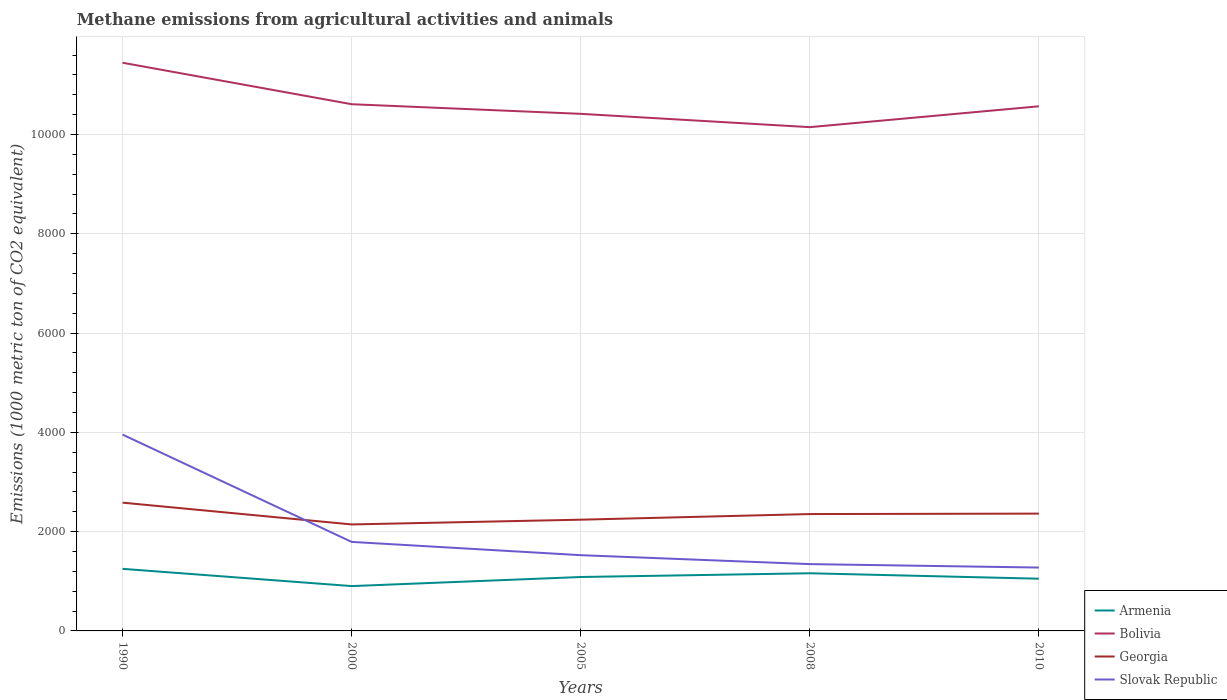Across all years, what is the maximum amount of methane emitted in Slovak Republic?
Provide a succinct answer. 1276.7. In which year was the amount of methane emitted in Armenia maximum?
Offer a terse response. 2000. What is the total amount of methane emitted in Armenia in the graph?
Give a very brief answer. 109.8. What is the difference between the highest and the second highest amount of methane emitted in Bolivia?
Provide a short and direct response. 1297.5. How many lines are there?
Keep it short and to the point. 4. What is the difference between two consecutive major ticks on the Y-axis?
Keep it short and to the point. 2000. Are the values on the major ticks of Y-axis written in scientific E-notation?
Your answer should be compact. No. Does the graph contain any zero values?
Provide a succinct answer. No. How many legend labels are there?
Provide a short and direct response. 4. What is the title of the graph?
Your answer should be very brief. Methane emissions from agricultural activities and animals. What is the label or title of the X-axis?
Your answer should be very brief. Years. What is the label or title of the Y-axis?
Offer a very short reply. Emissions (1000 metric ton of CO2 equivalent). What is the Emissions (1000 metric ton of CO2 equivalent) of Armenia in 1990?
Offer a terse response. 1250.4. What is the Emissions (1000 metric ton of CO2 equivalent) in Bolivia in 1990?
Provide a short and direct response. 1.14e+04. What is the Emissions (1000 metric ton of CO2 equivalent) of Georgia in 1990?
Keep it short and to the point. 2583.7. What is the Emissions (1000 metric ton of CO2 equivalent) in Slovak Republic in 1990?
Ensure brevity in your answer.  3954.5. What is the Emissions (1000 metric ton of CO2 equivalent) of Armenia in 2000?
Offer a terse response. 903.1. What is the Emissions (1000 metric ton of CO2 equivalent) of Bolivia in 2000?
Ensure brevity in your answer.  1.06e+04. What is the Emissions (1000 metric ton of CO2 equivalent) in Georgia in 2000?
Provide a succinct answer. 2145. What is the Emissions (1000 metric ton of CO2 equivalent) of Slovak Republic in 2000?
Provide a short and direct response. 1793.2. What is the Emissions (1000 metric ton of CO2 equivalent) of Armenia in 2005?
Your response must be concise. 1086. What is the Emissions (1000 metric ton of CO2 equivalent) of Bolivia in 2005?
Keep it short and to the point. 1.04e+04. What is the Emissions (1000 metric ton of CO2 equivalent) in Georgia in 2005?
Your response must be concise. 2240.7. What is the Emissions (1000 metric ton of CO2 equivalent) of Slovak Republic in 2005?
Make the answer very short. 1525.9. What is the Emissions (1000 metric ton of CO2 equivalent) in Armenia in 2008?
Make the answer very short. 1161.5. What is the Emissions (1000 metric ton of CO2 equivalent) of Bolivia in 2008?
Keep it short and to the point. 1.01e+04. What is the Emissions (1000 metric ton of CO2 equivalent) of Georgia in 2008?
Give a very brief answer. 2354. What is the Emissions (1000 metric ton of CO2 equivalent) of Slovak Republic in 2008?
Provide a succinct answer. 1345.7. What is the Emissions (1000 metric ton of CO2 equivalent) in Armenia in 2010?
Your answer should be compact. 1051.7. What is the Emissions (1000 metric ton of CO2 equivalent) of Bolivia in 2010?
Your response must be concise. 1.06e+04. What is the Emissions (1000 metric ton of CO2 equivalent) in Georgia in 2010?
Your answer should be compact. 2363.1. What is the Emissions (1000 metric ton of CO2 equivalent) in Slovak Republic in 2010?
Your answer should be compact. 1276.7. Across all years, what is the maximum Emissions (1000 metric ton of CO2 equivalent) of Armenia?
Provide a succinct answer. 1250.4. Across all years, what is the maximum Emissions (1000 metric ton of CO2 equivalent) of Bolivia?
Offer a terse response. 1.14e+04. Across all years, what is the maximum Emissions (1000 metric ton of CO2 equivalent) of Georgia?
Ensure brevity in your answer.  2583.7. Across all years, what is the maximum Emissions (1000 metric ton of CO2 equivalent) in Slovak Republic?
Provide a short and direct response. 3954.5. Across all years, what is the minimum Emissions (1000 metric ton of CO2 equivalent) in Armenia?
Make the answer very short. 903.1. Across all years, what is the minimum Emissions (1000 metric ton of CO2 equivalent) of Bolivia?
Provide a short and direct response. 1.01e+04. Across all years, what is the minimum Emissions (1000 metric ton of CO2 equivalent) in Georgia?
Your answer should be compact. 2145. Across all years, what is the minimum Emissions (1000 metric ton of CO2 equivalent) of Slovak Republic?
Make the answer very short. 1276.7. What is the total Emissions (1000 metric ton of CO2 equivalent) of Armenia in the graph?
Your answer should be very brief. 5452.7. What is the total Emissions (1000 metric ton of CO2 equivalent) in Bolivia in the graph?
Provide a short and direct response. 5.32e+04. What is the total Emissions (1000 metric ton of CO2 equivalent) in Georgia in the graph?
Provide a short and direct response. 1.17e+04. What is the total Emissions (1000 metric ton of CO2 equivalent) in Slovak Republic in the graph?
Give a very brief answer. 9896. What is the difference between the Emissions (1000 metric ton of CO2 equivalent) in Armenia in 1990 and that in 2000?
Provide a succinct answer. 347.3. What is the difference between the Emissions (1000 metric ton of CO2 equivalent) in Bolivia in 1990 and that in 2000?
Make the answer very short. 835.3. What is the difference between the Emissions (1000 metric ton of CO2 equivalent) in Georgia in 1990 and that in 2000?
Ensure brevity in your answer.  438.7. What is the difference between the Emissions (1000 metric ton of CO2 equivalent) of Slovak Republic in 1990 and that in 2000?
Your response must be concise. 2161.3. What is the difference between the Emissions (1000 metric ton of CO2 equivalent) in Armenia in 1990 and that in 2005?
Give a very brief answer. 164.4. What is the difference between the Emissions (1000 metric ton of CO2 equivalent) of Bolivia in 1990 and that in 2005?
Make the answer very short. 1029.2. What is the difference between the Emissions (1000 metric ton of CO2 equivalent) of Georgia in 1990 and that in 2005?
Offer a terse response. 343. What is the difference between the Emissions (1000 metric ton of CO2 equivalent) in Slovak Republic in 1990 and that in 2005?
Keep it short and to the point. 2428.6. What is the difference between the Emissions (1000 metric ton of CO2 equivalent) in Armenia in 1990 and that in 2008?
Offer a very short reply. 88.9. What is the difference between the Emissions (1000 metric ton of CO2 equivalent) of Bolivia in 1990 and that in 2008?
Provide a succinct answer. 1297.5. What is the difference between the Emissions (1000 metric ton of CO2 equivalent) of Georgia in 1990 and that in 2008?
Make the answer very short. 229.7. What is the difference between the Emissions (1000 metric ton of CO2 equivalent) of Slovak Republic in 1990 and that in 2008?
Your response must be concise. 2608.8. What is the difference between the Emissions (1000 metric ton of CO2 equivalent) in Armenia in 1990 and that in 2010?
Offer a very short reply. 198.7. What is the difference between the Emissions (1000 metric ton of CO2 equivalent) of Bolivia in 1990 and that in 2010?
Your response must be concise. 877.3. What is the difference between the Emissions (1000 metric ton of CO2 equivalent) in Georgia in 1990 and that in 2010?
Provide a short and direct response. 220.6. What is the difference between the Emissions (1000 metric ton of CO2 equivalent) in Slovak Republic in 1990 and that in 2010?
Keep it short and to the point. 2677.8. What is the difference between the Emissions (1000 metric ton of CO2 equivalent) of Armenia in 2000 and that in 2005?
Keep it short and to the point. -182.9. What is the difference between the Emissions (1000 metric ton of CO2 equivalent) in Bolivia in 2000 and that in 2005?
Your answer should be compact. 193.9. What is the difference between the Emissions (1000 metric ton of CO2 equivalent) in Georgia in 2000 and that in 2005?
Offer a very short reply. -95.7. What is the difference between the Emissions (1000 metric ton of CO2 equivalent) of Slovak Republic in 2000 and that in 2005?
Keep it short and to the point. 267.3. What is the difference between the Emissions (1000 metric ton of CO2 equivalent) in Armenia in 2000 and that in 2008?
Give a very brief answer. -258.4. What is the difference between the Emissions (1000 metric ton of CO2 equivalent) of Bolivia in 2000 and that in 2008?
Ensure brevity in your answer.  462.2. What is the difference between the Emissions (1000 metric ton of CO2 equivalent) in Georgia in 2000 and that in 2008?
Offer a very short reply. -209. What is the difference between the Emissions (1000 metric ton of CO2 equivalent) in Slovak Republic in 2000 and that in 2008?
Keep it short and to the point. 447.5. What is the difference between the Emissions (1000 metric ton of CO2 equivalent) of Armenia in 2000 and that in 2010?
Offer a very short reply. -148.6. What is the difference between the Emissions (1000 metric ton of CO2 equivalent) of Bolivia in 2000 and that in 2010?
Your response must be concise. 42. What is the difference between the Emissions (1000 metric ton of CO2 equivalent) in Georgia in 2000 and that in 2010?
Give a very brief answer. -218.1. What is the difference between the Emissions (1000 metric ton of CO2 equivalent) of Slovak Republic in 2000 and that in 2010?
Provide a succinct answer. 516.5. What is the difference between the Emissions (1000 metric ton of CO2 equivalent) in Armenia in 2005 and that in 2008?
Ensure brevity in your answer.  -75.5. What is the difference between the Emissions (1000 metric ton of CO2 equivalent) of Bolivia in 2005 and that in 2008?
Keep it short and to the point. 268.3. What is the difference between the Emissions (1000 metric ton of CO2 equivalent) in Georgia in 2005 and that in 2008?
Provide a short and direct response. -113.3. What is the difference between the Emissions (1000 metric ton of CO2 equivalent) of Slovak Republic in 2005 and that in 2008?
Your response must be concise. 180.2. What is the difference between the Emissions (1000 metric ton of CO2 equivalent) in Armenia in 2005 and that in 2010?
Provide a succinct answer. 34.3. What is the difference between the Emissions (1000 metric ton of CO2 equivalent) in Bolivia in 2005 and that in 2010?
Give a very brief answer. -151.9. What is the difference between the Emissions (1000 metric ton of CO2 equivalent) in Georgia in 2005 and that in 2010?
Ensure brevity in your answer.  -122.4. What is the difference between the Emissions (1000 metric ton of CO2 equivalent) of Slovak Republic in 2005 and that in 2010?
Your response must be concise. 249.2. What is the difference between the Emissions (1000 metric ton of CO2 equivalent) of Armenia in 2008 and that in 2010?
Your answer should be very brief. 109.8. What is the difference between the Emissions (1000 metric ton of CO2 equivalent) of Bolivia in 2008 and that in 2010?
Keep it short and to the point. -420.2. What is the difference between the Emissions (1000 metric ton of CO2 equivalent) of Georgia in 2008 and that in 2010?
Make the answer very short. -9.1. What is the difference between the Emissions (1000 metric ton of CO2 equivalent) in Armenia in 1990 and the Emissions (1000 metric ton of CO2 equivalent) in Bolivia in 2000?
Provide a succinct answer. -9359.3. What is the difference between the Emissions (1000 metric ton of CO2 equivalent) in Armenia in 1990 and the Emissions (1000 metric ton of CO2 equivalent) in Georgia in 2000?
Your answer should be compact. -894.6. What is the difference between the Emissions (1000 metric ton of CO2 equivalent) of Armenia in 1990 and the Emissions (1000 metric ton of CO2 equivalent) of Slovak Republic in 2000?
Provide a short and direct response. -542.8. What is the difference between the Emissions (1000 metric ton of CO2 equivalent) of Bolivia in 1990 and the Emissions (1000 metric ton of CO2 equivalent) of Georgia in 2000?
Keep it short and to the point. 9300. What is the difference between the Emissions (1000 metric ton of CO2 equivalent) of Bolivia in 1990 and the Emissions (1000 metric ton of CO2 equivalent) of Slovak Republic in 2000?
Your answer should be compact. 9651.8. What is the difference between the Emissions (1000 metric ton of CO2 equivalent) of Georgia in 1990 and the Emissions (1000 metric ton of CO2 equivalent) of Slovak Republic in 2000?
Make the answer very short. 790.5. What is the difference between the Emissions (1000 metric ton of CO2 equivalent) in Armenia in 1990 and the Emissions (1000 metric ton of CO2 equivalent) in Bolivia in 2005?
Your response must be concise. -9165.4. What is the difference between the Emissions (1000 metric ton of CO2 equivalent) of Armenia in 1990 and the Emissions (1000 metric ton of CO2 equivalent) of Georgia in 2005?
Provide a short and direct response. -990.3. What is the difference between the Emissions (1000 metric ton of CO2 equivalent) in Armenia in 1990 and the Emissions (1000 metric ton of CO2 equivalent) in Slovak Republic in 2005?
Your answer should be very brief. -275.5. What is the difference between the Emissions (1000 metric ton of CO2 equivalent) of Bolivia in 1990 and the Emissions (1000 metric ton of CO2 equivalent) of Georgia in 2005?
Ensure brevity in your answer.  9204.3. What is the difference between the Emissions (1000 metric ton of CO2 equivalent) in Bolivia in 1990 and the Emissions (1000 metric ton of CO2 equivalent) in Slovak Republic in 2005?
Make the answer very short. 9919.1. What is the difference between the Emissions (1000 metric ton of CO2 equivalent) in Georgia in 1990 and the Emissions (1000 metric ton of CO2 equivalent) in Slovak Republic in 2005?
Give a very brief answer. 1057.8. What is the difference between the Emissions (1000 metric ton of CO2 equivalent) of Armenia in 1990 and the Emissions (1000 metric ton of CO2 equivalent) of Bolivia in 2008?
Your answer should be compact. -8897.1. What is the difference between the Emissions (1000 metric ton of CO2 equivalent) of Armenia in 1990 and the Emissions (1000 metric ton of CO2 equivalent) of Georgia in 2008?
Make the answer very short. -1103.6. What is the difference between the Emissions (1000 metric ton of CO2 equivalent) of Armenia in 1990 and the Emissions (1000 metric ton of CO2 equivalent) of Slovak Republic in 2008?
Your answer should be very brief. -95.3. What is the difference between the Emissions (1000 metric ton of CO2 equivalent) of Bolivia in 1990 and the Emissions (1000 metric ton of CO2 equivalent) of Georgia in 2008?
Give a very brief answer. 9091. What is the difference between the Emissions (1000 metric ton of CO2 equivalent) of Bolivia in 1990 and the Emissions (1000 metric ton of CO2 equivalent) of Slovak Republic in 2008?
Offer a very short reply. 1.01e+04. What is the difference between the Emissions (1000 metric ton of CO2 equivalent) in Georgia in 1990 and the Emissions (1000 metric ton of CO2 equivalent) in Slovak Republic in 2008?
Offer a terse response. 1238. What is the difference between the Emissions (1000 metric ton of CO2 equivalent) in Armenia in 1990 and the Emissions (1000 metric ton of CO2 equivalent) in Bolivia in 2010?
Provide a short and direct response. -9317.3. What is the difference between the Emissions (1000 metric ton of CO2 equivalent) of Armenia in 1990 and the Emissions (1000 metric ton of CO2 equivalent) of Georgia in 2010?
Provide a short and direct response. -1112.7. What is the difference between the Emissions (1000 metric ton of CO2 equivalent) in Armenia in 1990 and the Emissions (1000 metric ton of CO2 equivalent) in Slovak Republic in 2010?
Offer a very short reply. -26.3. What is the difference between the Emissions (1000 metric ton of CO2 equivalent) in Bolivia in 1990 and the Emissions (1000 metric ton of CO2 equivalent) in Georgia in 2010?
Your answer should be very brief. 9081.9. What is the difference between the Emissions (1000 metric ton of CO2 equivalent) in Bolivia in 1990 and the Emissions (1000 metric ton of CO2 equivalent) in Slovak Republic in 2010?
Your answer should be compact. 1.02e+04. What is the difference between the Emissions (1000 metric ton of CO2 equivalent) in Georgia in 1990 and the Emissions (1000 metric ton of CO2 equivalent) in Slovak Republic in 2010?
Your answer should be compact. 1307. What is the difference between the Emissions (1000 metric ton of CO2 equivalent) of Armenia in 2000 and the Emissions (1000 metric ton of CO2 equivalent) of Bolivia in 2005?
Keep it short and to the point. -9512.7. What is the difference between the Emissions (1000 metric ton of CO2 equivalent) of Armenia in 2000 and the Emissions (1000 metric ton of CO2 equivalent) of Georgia in 2005?
Offer a very short reply. -1337.6. What is the difference between the Emissions (1000 metric ton of CO2 equivalent) in Armenia in 2000 and the Emissions (1000 metric ton of CO2 equivalent) in Slovak Republic in 2005?
Your response must be concise. -622.8. What is the difference between the Emissions (1000 metric ton of CO2 equivalent) in Bolivia in 2000 and the Emissions (1000 metric ton of CO2 equivalent) in Georgia in 2005?
Provide a short and direct response. 8369. What is the difference between the Emissions (1000 metric ton of CO2 equivalent) of Bolivia in 2000 and the Emissions (1000 metric ton of CO2 equivalent) of Slovak Republic in 2005?
Make the answer very short. 9083.8. What is the difference between the Emissions (1000 metric ton of CO2 equivalent) in Georgia in 2000 and the Emissions (1000 metric ton of CO2 equivalent) in Slovak Republic in 2005?
Ensure brevity in your answer.  619.1. What is the difference between the Emissions (1000 metric ton of CO2 equivalent) of Armenia in 2000 and the Emissions (1000 metric ton of CO2 equivalent) of Bolivia in 2008?
Your answer should be very brief. -9244.4. What is the difference between the Emissions (1000 metric ton of CO2 equivalent) in Armenia in 2000 and the Emissions (1000 metric ton of CO2 equivalent) in Georgia in 2008?
Make the answer very short. -1450.9. What is the difference between the Emissions (1000 metric ton of CO2 equivalent) of Armenia in 2000 and the Emissions (1000 metric ton of CO2 equivalent) of Slovak Republic in 2008?
Your response must be concise. -442.6. What is the difference between the Emissions (1000 metric ton of CO2 equivalent) of Bolivia in 2000 and the Emissions (1000 metric ton of CO2 equivalent) of Georgia in 2008?
Offer a terse response. 8255.7. What is the difference between the Emissions (1000 metric ton of CO2 equivalent) of Bolivia in 2000 and the Emissions (1000 metric ton of CO2 equivalent) of Slovak Republic in 2008?
Keep it short and to the point. 9264. What is the difference between the Emissions (1000 metric ton of CO2 equivalent) in Georgia in 2000 and the Emissions (1000 metric ton of CO2 equivalent) in Slovak Republic in 2008?
Your response must be concise. 799.3. What is the difference between the Emissions (1000 metric ton of CO2 equivalent) of Armenia in 2000 and the Emissions (1000 metric ton of CO2 equivalent) of Bolivia in 2010?
Provide a succinct answer. -9664.6. What is the difference between the Emissions (1000 metric ton of CO2 equivalent) of Armenia in 2000 and the Emissions (1000 metric ton of CO2 equivalent) of Georgia in 2010?
Give a very brief answer. -1460. What is the difference between the Emissions (1000 metric ton of CO2 equivalent) in Armenia in 2000 and the Emissions (1000 metric ton of CO2 equivalent) in Slovak Republic in 2010?
Keep it short and to the point. -373.6. What is the difference between the Emissions (1000 metric ton of CO2 equivalent) of Bolivia in 2000 and the Emissions (1000 metric ton of CO2 equivalent) of Georgia in 2010?
Provide a succinct answer. 8246.6. What is the difference between the Emissions (1000 metric ton of CO2 equivalent) of Bolivia in 2000 and the Emissions (1000 metric ton of CO2 equivalent) of Slovak Republic in 2010?
Offer a terse response. 9333. What is the difference between the Emissions (1000 metric ton of CO2 equivalent) in Georgia in 2000 and the Emissions (1000 metric ton of CO2 equivalent) in Slovak Republic in 2010?
Your response must be concise. 868.3. What is the difference between the Emissions (1000 metric ton of CO2 equivalent) of Armenia in 2005 and the Emissions (1000 metric ton of CO2 equivalent) of Bolivia in 2008?
Offer a very short reply. -9061.5. What is the difference between the Emissions (1000 metric ton of CO2 equivalent) in Armenia in 2005 and the Emissions (1000 metric ton of CO2 equivalent) in Georgia in 2008?
Provide a succinct answer. -1268. What is the difference between the Emissions (1000 metric ton of CO2 equivalent) of Armenia in 2005 and the Emissions (1000 metric ton of CO2 equivalent) of Slovak Republic in 2008?
Ensure brevity in your answer.  -259.7. What is the difference between the Emissions (1000 metric ton of CO2 equivalent) of Bolivia in 2005 and the Emissions (1000 metric ton of CO2 equivalent) of Georgia in 2008?
Your response must be concise. 8061.8. What is the difference between the Emissions (1000 metric ton of CO2 equivalent) in Bolivia in 2005 and the Emissions (1000 metric ton of CO2 equivalent) in Slovak Republic in 2008?
Provide a succinct answer. 9070.1. What is the difference between the Emissions (1000 metric ton of CO2 equivalent) of Georgia in 2005 and the Emissions (1000 metric ton of CO2 equivalent) of Slovak Republic in 2008?
Ensure brevity in your answer.  895. What is the difference between the Emissions (1000 metric ton of CO2 equivalent) of Armenia in 2005 and the Emissions (1000 metric ton of CO2 equivalent) of Bolivia in 2010?
Your response must be concise. -9481.7. What is the difference between the Emissions (1000 metric ton of CO2 equivalent) in Armenia in 2005 and the Emissions (1000 metric ton of CO2 equivalent) in Georgia in 2010?
Provide a short and direct response. -1277.1. What is the difference between the Emissions (1000 metric ton of CO2 equivalent) of Armenia in 2005 and the Emissions (1000 metric ton of CO2 equivalent) of Slovak Republic in 2010?
Your answer should be very brief. -190.7. What is the difference between the Emissions (1000 metric ton of CO2 equivalent) in Bolivia in 2005 and the Emissions (1000 metric ton of CO2 equivalent) in Georgia in 2010?
Offer a terse response. 8052.7. What is the difference between the Emissions (1000 metric ton of CO2 equivalent) of Bolivia in 2005 and the Emissions (1000 metric ton of CO2 equivalent) of Slovak Republic in 2010?
Keep it short and to the point. 9139.1. What is the difference between the Emissions (1000 metric ton of CO2 equivalent) of Georgia in 2005 and the Emissions (1000 metric ton of CO2 equivalent) of Slovak Republic in 2010?
Provide a succinct answer. 964. What is the difference between the Emissions (1000 metric ton of CO2 equivalent) in Armenia in 2008 and the Emissions (1000 metric ton of CO2 equivalent) in Bolivia in 2010?
Ensure brevity in your answer.  -9406.2. What is the difference between the Emissions (1000 metric ton of CO2 equivalent) of Armenia in 2008 and the Emissions (1000 metric ton of CO2 equivalent) of Georgia in 2010?
Your response must be concise. -1201.6. What is the difference between the Emissions (1000 metric ton of CO2 equivalent) of Armenia in 2008 and the Emissions (1000 metric ton of CO2 equivalent) of Slovak Republic in 2010?
Make the answer very short. -115.2. What is the difference between the Emissions (1000 metric ton of CO2 equivalent) in Bolivia in 2008 and the Emissions (1000 metric ton of CO2 equivalent) in Georgia in 2010?
Provide a short and direct response. 7784.4. What is the difference between the Emissions (1000 metric ton of CO2 equivalent) in Bolivia in 2008 and the Emissions (1000 metric ton of CO2 equivalent) in Slovak Republic in 2010?
Make the answer very short. 8870.8. What is the difference between the Emissions (1000 metric ton of CO2 equivalent) in Georgia in 2008 and the Emissions (1000 metric ton of CO2 equivalent) in Slovak Republic in 2010?
Ensure brevity in your answer.  1077.3. What is the average Emissions (1000 metric ton of CO2 equivalent) of Armenia per year?
Offer a very short reply. 1090.54. What is the average Emissions (1000 metric ton of CO2 equivalent) in Bolivia per year?
Provide a short and direct response. 1.06e+04. What is the average Emissions (1000 metric ton of CO2 equivalent) of Georgia per year?
Provide a succinct answer. 2337.3. What is the average Emissions (1000 metric ton of CO2 equivalent) of Slovak Republic per year?
Give a very brief answer. 1979.2. In the year 1990, what is the difference between the Emissions (1000 metric ton of CO2 equivalent) of Armenia and Emissions (1000 metric ton of CO2 equivalent) of Bolivia?
Provide a short and direct response. -1.02e+04. In the year 1990, what is the difference between the Emissions (1000 metric ton of CO2 equivalent) of Armenia and Emissions (1000 metric ton of CO2 equivalent) of Georgia?
Ensure brevity in your answer.  -1333.3. In the year 1990, what is the difference between the Emissions (1000 metric ton of CO2 equivalent) of Armenia and Emissions (1000 metric ton of CO2 equivalent) of Slovak Republic?
Provide a succinct answer. -2704.1. In the year 1990, what is the difference between the Emissions (1000 metric ton of CO2 equivalent) in Bolivia and Emissions (1000 metric ton of CO2 equivalent) in Georgia?
Give a very brief answer. 8861.3. In the year 1990, what is the difference between the Emissions (1000 metric ton of CO2 equivalent) of Bolivia and Emissions (1000 metric ton of CO2 equivalent) of Slovak Republic?
Your answer should be compact. 7490.5. In the year 1990, what is the difference between the Emissions (1000 metric ton of CO2 equivalent) in Georgia and Emissions (1000 metric ton of CO2 equivalent) in Slovak Republic?
Offer a very short reply. -1370.8. In the year 2000, what is the difference between the Emissions (1000 metric ton of CO2 equivalent) in Armenia and Emissions (1000 metric ton of CO2 equivalent) in Bolivia?
Ensure brevity in your answer.  -9706.6. In the year 2000, what is the difference between the Emissions (1000 metric ton of CO2 equivalent) in Armenia and Emissions (1000 metric ton of CO2 equivalent) in Georgia?
Your response must be concise. -1241.9. In the year 2000, what is the difference between the Emissions (1000 metric ton of CO2 equivalent) in Armenia and Emissions (1000 metric ton of CO2 equivalent) in Slovak Republic?
Provide a succinct answer. -890.1. In the year 2000, what is the difference between the Emissions (1000 metric ton of CO2 equivalent) of Bolivia and Emissions (1000 metric ton of CO2 equivalent) of Georgia?
Offer a very short reply. 8464.7. In the year 2000, what is the difference between the Emissions (1000 metric ton of CO2 equivalent) in Bolivia and Emissions (1000 metric ton of CO2 equivalent) in Slovak Republic?
Your answer should be compact. 8816.5. In the year 2000, what is the difference between the Emissions (1000 metric ton of CO2 equivalent) in Georgia and Emissions (1000 metric ton of CO2 equivalent) in Slovak Republic?
Give a very brief answer. 351.8. In the year 2005, what is the difference between the Emissions (1000 metric ton of CO2 equivalent) in Armenia and Emissions (1000 metric ton of CO2 equivalent) in Bolivia?
Make the answer very short. -9329.8. In the year 2005, what is the difference between the Emissions (1000 metric ton of CO2 equivalent) of Armenia and Emissions (1000 metric ton of CO2 equivalent) of Georgia?
Your answer should be compact. -1154.7. In the year 2005, what is the difference between the Emissions (1000 metric ton of CO2 equivalent) of Armenia and Emissions (1000 metric ton of CO2 equivalent) of Slovak Republic?
Your answer should be compact. -439.9. In the year 2005, what is the difference between the Emissions (1000 metric ton of CO2 equivalent) in Bolivia and Emissions (1000 metric ton of CO2 equivalent) in Georgia?
Give a very brief answer. 8175.1. In the year 2005, what is the difference between the Emissions (1000 metric ton of CO2 equivalent) in Bolivia and Emissions (1000 metric ton of CO2 equivalent) in Slovak Republic?
Ensure brevity in your answer.  8889.9. In the year 2005, what is the difference between the Emissions (1000 metric ton of CO2 equivalent) of Georgia and Emissions (1000 metric ton of CO2 equivalent) of Slovak Republic?
Provide a succinct answer. 714.8. In the year 2008, what is the difference between the Emissions (1000 metric ton of CO2 equivalent) of Armenia and Emissions (1000 metric ton of CO2 equivalent) of Bolivia?
Make the answer very short. -8986. In the year 2008, what is the difference between the Emissions (1000 metric ton of CO2 equivalent) in Armenia and Emissions (1000 metric ton of CO2 equivalent) in Georgia?
Your response must be concise. -1192.5. In the year 2008, what is the difference between the Emissions (1000 metric ton of CO2 equivalent) of Armenia and Emissions (1000 metric ton of CO2 equivalent) of Slovak Republic?
Provide a succinct answer. -184.2. In the year 2008, what is the difference between the Emissions (1000 metric ton of CO2 equivalent) of Bolivia and Emissions (1000 metric ton of CO2 equivalent) of Georgia?
Offer a terse response. 7793.5. In the year 2008, what is the difference between the Emissions (1000 metric ton of CO2 equivalent) in Bolivia and Emissions (1000 metric ton of CO2 equivalent) in Slovak Republic?
Offer a terse response. 8801.8. In the year 2008, what is the difference between the Emissions (1000 metric ton of CO2 equivalent) of Georgia and Emissions (1000 metric ton of CO2 equivalent) of Slovak Republic?
Ensure brevity in your answer.  1008.3. In the year 2010, what is the difference between the Emissions (1000 metric ton of CO2 equivalent) in Armenia and Emissions (1000 metric ton of CO2 equivalent) in Bolivia?
Your answer should be compact. -9516. In the year 2010, what is the difference between the Emissions (1000 metric ton of CO2 equivalent) of Armenia and Emissions (1000 metric ton of CO2 equivalent) of Georgia?
Keep it short and to the point. -1311.4. In the year 2010, what is the difference between the Emissions (1000 metric ton of CO2 equivalent) of Armenia and Emissions (1000 metric ton of CO2 equivalent) of Slovak Republic?
Offer a very short reply. -225. In the year 2010, what is the difference between the Emissions (1000 metric ton of CO2 equivalent) in Bolivia and Emissions (1000 metric ton of CO2 equivalent) in Georgia?
Provide a succinct answer. 8204.6. In the year 2010, what is the difference between the Emissions (1000 metric ton of CO2 equivalent) in Bolivia and Emissions (1000 metric ton of CO2 equivalent) in Slovak Republic?
Keep it short and to the point. 9291. In the year 2010, what is the difference between the Emissions (1000 metric ton of CO2 equivalent) in Georgia and Emissions (1000 metric ton of CO2 equivalent) in Slovak Republic?
Keep it short and to the point. 1086.4. What is the ratio of the Emissions (1000 metric ton of CO2 equivalent) of Armenia in 1990 to that in 2000?
Your response must be concise. 1.38. What is the ratio of the Emissions (1000 metric ton of CO2 equivalent) in Bolivia in 1990 to that in 2000?
Your answer should be compact. 1.08. What is the ratio of the Emissions (1000 metric ton of CO2 equivalent) in Georgia in 1990 to that in 2000?
Offer a very short reply. 1.2. What is the ratio of the Emissions (1000 metric ton of CO2 equivalent) in Slovak Republic in 1990 to that in 2000?
Your answer should be very brief. 2.21. What is the ratio of the Emissions (1000 metric ton of CO2 equivalent) of Armenia in 1990 to that in 2005?
Give a very brief answer. 1.15. What is the ratio of the Emissions (1000 metric ton of CO2 equivalent) of Bolivia in 1990 to that in 2005?
Your response must be concise. 1.1. What is the ratio of the Emissions (1000 metric ton of CO2 equivalent) of Georgia in 1990 to that in 2005?
Make the answer very short. 1.15. What is the ratio of the Emissions (1000 metric ton of CO2 equivalent) in Slovak Republic in 1990 to that in 2005?
Your answer should be very brief. 2.59. What is the ratio of the Emissions (1000 metric ton of CO2 equivalent) in Armenia in 1990 to that in 2008?
Provide a short and direct response. 1.08. What is the ratio of the Emissions (1000 metric ton of CO2 equivalent) in Bolivia in 1990 to that in 2008?
Make the answer very short. 1.13. What is the ratio of the Emissions (1000 metric ton of CO2 equivalent) in Georgia in 1990 to that in 2008?
Your answer should be very brief. 1.1. What is the ratio of the Emissions (1000 metric ton of CO2 equivalent) of Slovak Republic in 1990 to that in 2008?
Your response must be concise. 2.94. What is the ratio of the Emissions (1000 metric ton of CO2 equivalent) in Armenia in 1990 to that in 2010?
Offer a very short reply. 1.19. What is the ratio of the Emissions (1000 metric ton of CO2 equivalent) in Bolivia in 1990 to that in 2010?
Provide a succinct answer. 1.08. What is the ratio of the Emissions (1000 metric ton of CO2 equivalent) in Georgia in 1990 to that in 2010?
Keep it short and to the point. 1.09. What is the ratio of the Emissions (1000 metric ton of CO2 equivalent) of Slovak Republic in 1990 to that in 2010?
Your answer should be compact. 3.1. What is the ratio of the Emissions (1000 metric ton of CO2 equivalent) in Armenia in 2000 to that in 2005?
Your answer should be very brief. 0.83. What is the ratio of the Emissions (1000 metric ton of CO2 equivalent) in Bolivia in 2000 to that in 2005?
Make the answer very short. 1.02. What is the ratio of the Emissions (1000 metric ton of CO2 equivalent) of Georgia in 2000 to that in 2005?
Offer a terse response. 0.96. What is the ratio of the Emissions (1000 metric ton of CO2 equivalent) of Slovak Republic in 2000 to that in 2005?
Keep it short and to the point. 1.18. What is the ratio of the Emissions (1000 metric ton of CO2 equivalent) in Armenia in 2000 to that in 2008?
Your answer should be compact. 0.78. What is the ratio of the Emissions (1000 metric ton of CO2 equivalent) of Bolivia in 2000 to that in 2008?
Your answer should be compact. 1.05. What is the ratio of the Emissions (1000 metric ton of CO2 equivalent) in Georgia in 2000 to that in 2008?
Your answer should be compact. 0.91. What is the ratio of the Emissions (1000 metric ton of CO2 equivalent) of Slovak Republic in 2000 to that in 2008?
Your response must be concise. 1.33. What is the ratio of the Emissions (1000 metric ton of CO2 equivalent) in Armenia in 2000 to that in 2010?
Provide a succinct answer. 0.86. What is the ratio of the Emissions (1000 metric ton of CO2 equivalent) in Georgia in 2000 to that in 2010?
Offer a terse response. 0.91. What is the ratio of the Emissions (1000 metric ton of CO2 equivalent) in Slovak Republic in 2000 to that in 2010?
Give a very brief answer. 1.4. What is the ratio of the Emissions (1000 metric ton of CO2 equivalent) of Armenia in 2005 to that in 2008?
Your response must be concise. 0.94. What is the ratio of the Emissions (1000 metric ton of CO2 equivalent) in Bolivia in 2005 to that in 2008?
Provide a short and direct response. 1.03. What is the ratio of the Emissions (1000 metric ton of CO2 equivalent) of Georgia in 2005 to that in 2008?
Make the answer very short. 0.95. What is the ratio of the Emissions (1000 metric ton of CO2 equivalent) in Slovak Republic in 2005 to that in 2008?
Provide a short and direct response. 1.13. What is the ratio of the Emissions (1000 metric ton of CO2 equivalent) in Armenia in 2005 to that in 2010?
Give a very brief answer. 1.03. What is the ratio of the Emissions (1000 metric ton of CO2 equivalent) of Bolivia in 2005 to that in 2010?
Offer a very short reply. 0.99. What is the ratio of the Emissions (1000 metric ton of CO2 equivalent) in Georgia in 2005 to that in 2010?
Provide a succinct answer. 0.95. What is the ratio of the Emissions (1000 metric ton of CO2 equivalent) in Slovak Republic in 2005 to that in 2010?
Provide a short and direct response. 1.2. What is the ratio of the Emissions (1000 metric ton of CO2 equivalent) in Armenia in 2008 to that in 2010?
Ensure brevity in your answer.  1.1. What is the ratio of the Emissions (1000 metric ton of CO2 equivalent) of Bolivia in 2008 to that in 2010?
Make the answer very short. 0.96. What is the ratio of the Emissions (1000 metric ton of CO2 equivalent) of Slovak Republic in 2008 to that in 2010?
Provide a succinct answer. 1.05. What is the difference between the highest and the second highest Emissions (1000 metric ton of CO2 equivalent) in Armenia?
Your response must be concise. 88.9. What is the difference between the highest and the second highest Emissions (1000 metric ton of CO2 equivalent) in Bolivia?
Provide a short and direct response. 835.3. What is the difference between the highest and the second highest Emissions (1000 metric ton of CO2 equivalent) of Georgia?
Give a very brief answer. 220.6. What is the difference between the highest and the second highest Emissions (1000 metric ton of CO2 equivalent) in Slovak Republic?
Ensure brevity in your answer.  2161.3. What is the difference between the highest and the lowest Emissions (1000 metric ton of CO2 equivalent) in Armenia?
Give a very brief answer. 347.3. What is the difference between the highest and the lowest Emissions (1000 metric ton of CO2 equivalent) in Bolivia?
Keep it short and to the point. 1297.5. What is the difference between the highest and the lowest Emissions (1000 metric ton of CO2 equivalent) in Georgia?
Offer a terse response. 438.7. What is the difference between the highest and the lowest Emissions (1000 metric ton of CO2 equivalent) of Slovak Republic?
Ensure brevity in your answer.  2677.8. 